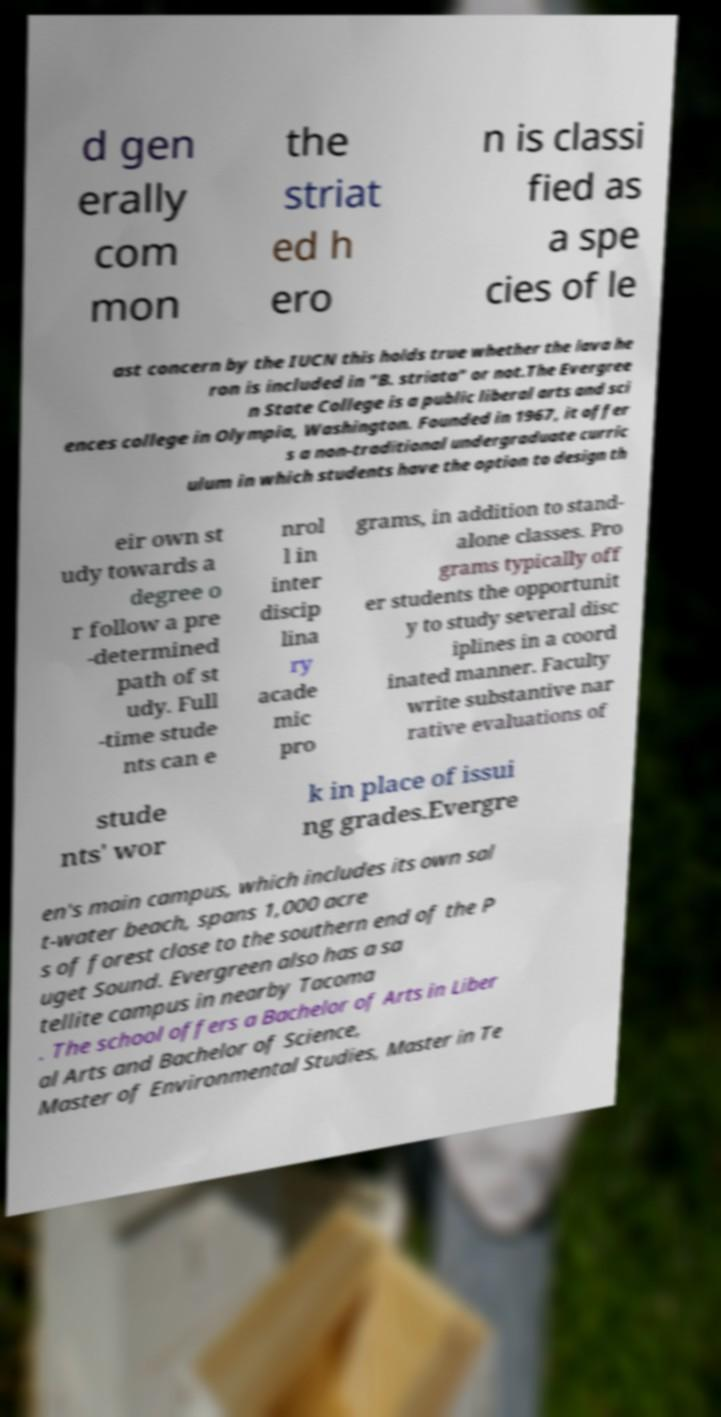Please identify and transcribe the text found in this image. d gen erally com mon the striat ed h ero n is classi fied as a spe cies of le ast concern by the IUCN this holds true whether the lava he ron is included in "B. striata" or not.The Evergree n State College is a public liberal arts and sci ences college in Olympia, Washington. Founded in 1967, it offer s a non-traditional undergraduate curric ulum in which students have the option to design th eir own st udy towards a degree o r follow a pre -determined path of st udy. Full -time stude nts can e nrol l in inter discip lina ry acade mic pro grams, in addition to stand- alone classes. Pro grams typically off er students the opportunit y to study several disc iplines in a coord inated manner. Faculty write substantive nar rative evaluations of stude nts' wor k in place of issui ng grades.Evergre en's main campus, which includes its own sal t-water beach, spans 1,000 acre s of forest close to the southern end of the P uget Sound. Evergreen also has a sa tellite campus in nearby Tacoma . The school offers a Bachelor of Arts in Liber al Arts and Bachelor of Science, Master of Environmental Studies, Master in Te 